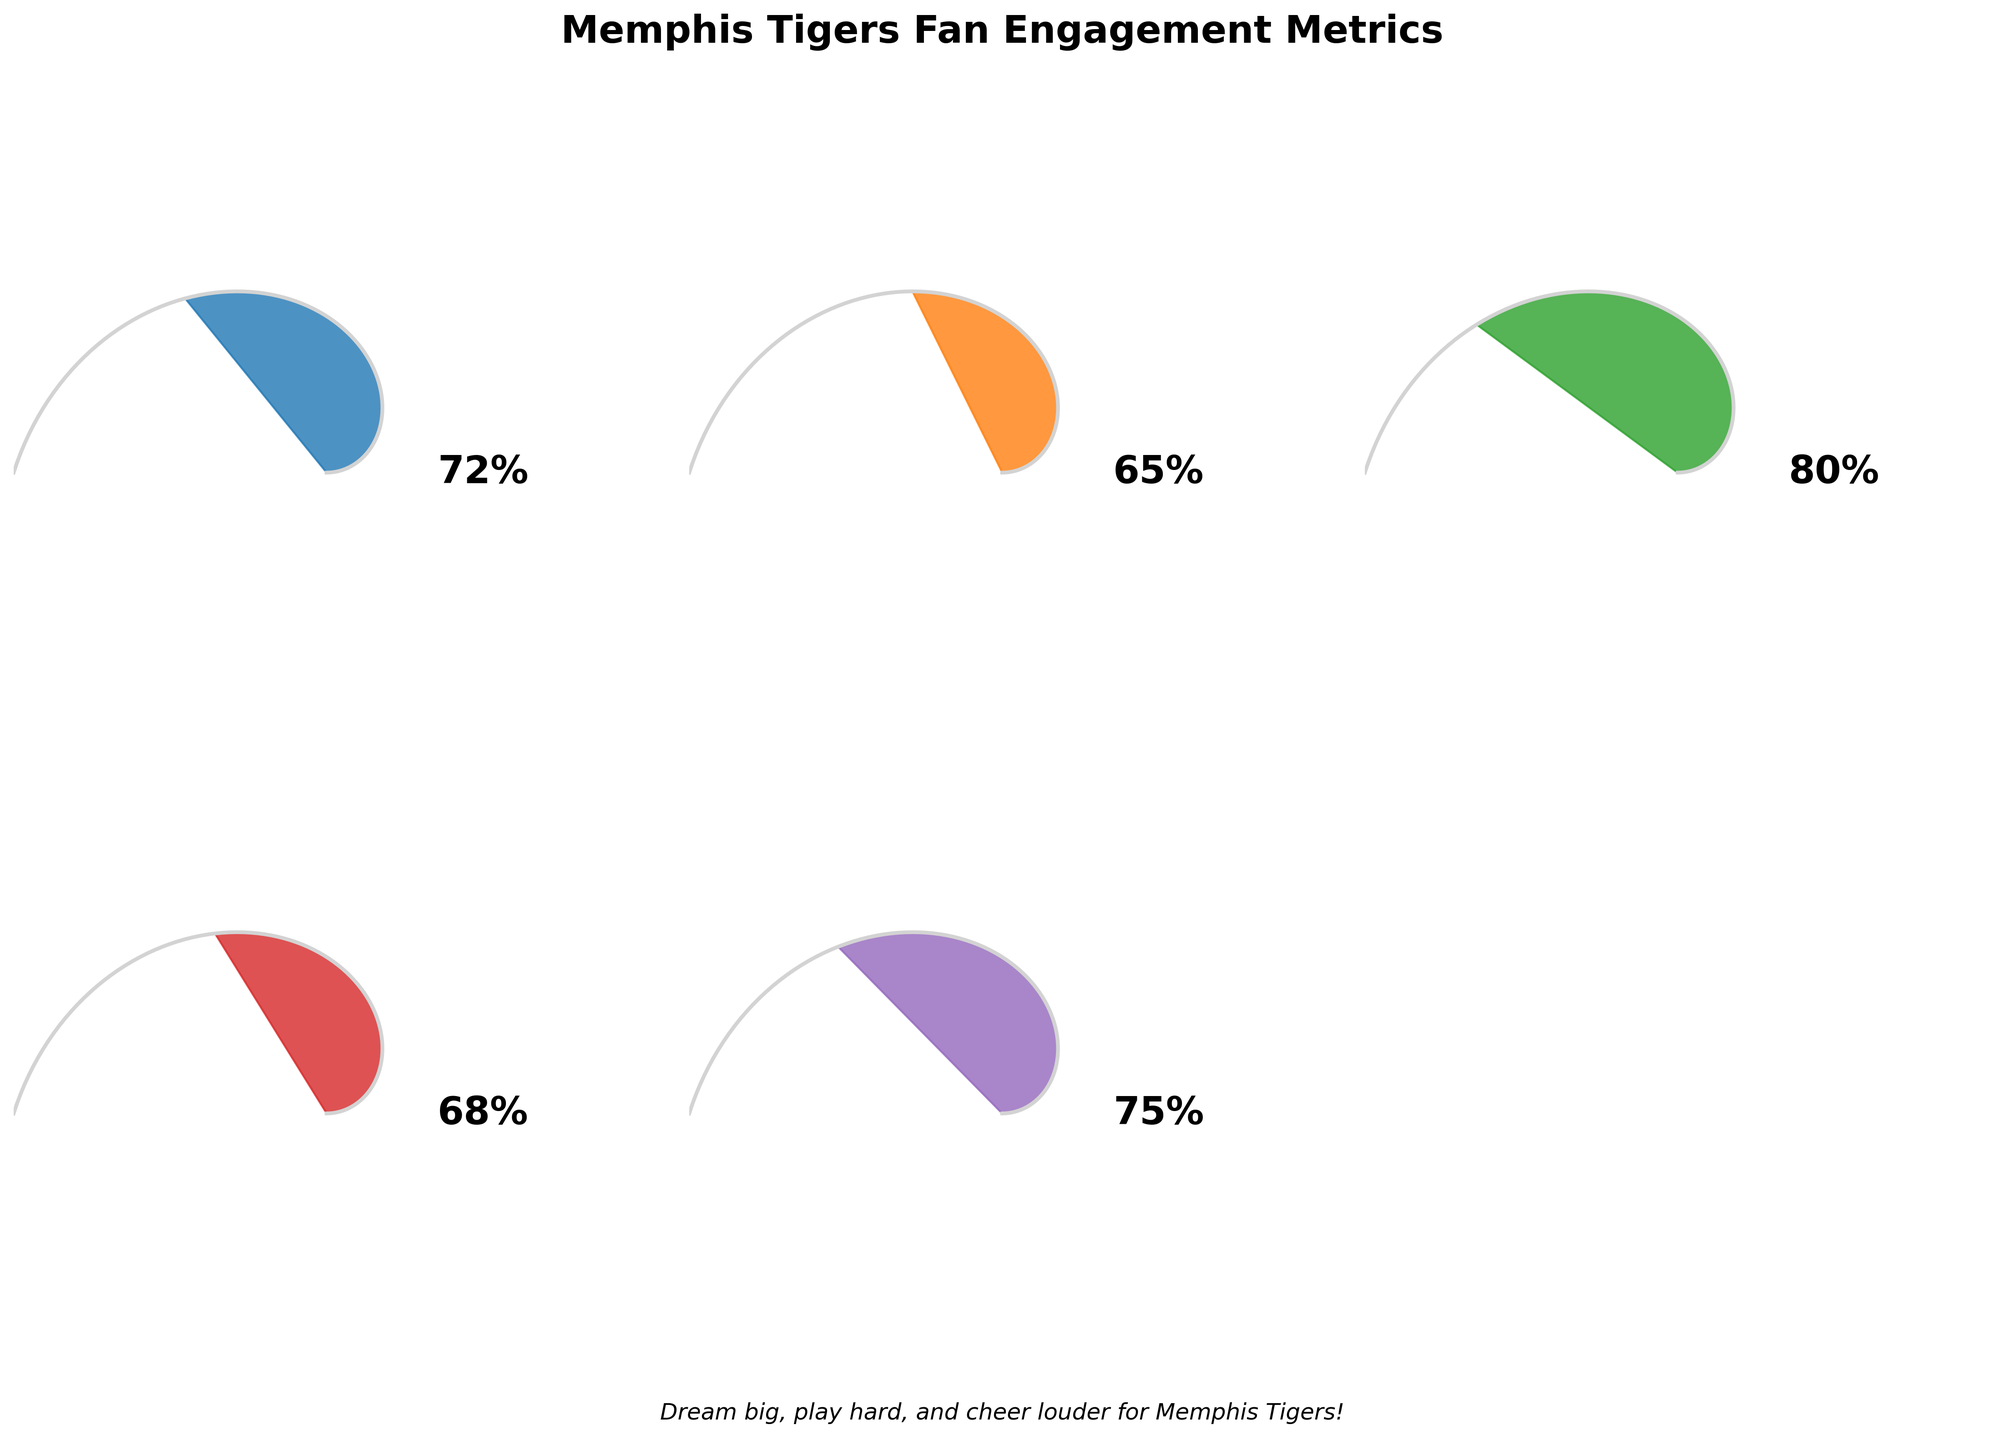What's the Memphis Tigers Fan Engagement Score? The gauge chart for Memphis Tigers Fan Engagement Score shows a value at the top, which reads 72%.
Answer: 72% How does the Liberty Bowl Memorial Stadium Attendance Rate compare to the Merchandise Sales Performance? From the two gauge charts, the Liberty Bowl Memorial Stadium Attendance Rate shows 65%, while Merchandise Sales Performance shows 68%. Thus, the Merchandise Sales Performance is a bit higher.
Answer: Merchandise Sales Performance is 3% higher Which metric scores the highest and what is its value? On examining all gauge charts, the Social Media Interaction Score has the highest value among the shown metrics, which is at 80%.
Answer: Social Media Interaction Score, 80% What is the average score across all shown metrics? Adding up all the values: 72 + 65 + 80 + 68 + 75 = 360. Dividing by the number of metrics (5) gives the average: 360 / 5 = 72.
Answer: 72 Between the Local TV Ratings for Tigers Games and Liberty Bowl Memorial Stadium Attendance Rate, which one has a superior score? Comparing the two metrics, Local TV Ratings for Tigers Games scores 75%, while Liberty Bowl Memorial Stadium Attendance Rate scores 65%. Thus, Local TV Ratings is higher.
Answer: Local TV Ratings for Tigers Games What color is used for the Social Media Interaction Score gauge? The color associated with the Social Media Interaction Score gauge is the fifth color in the sequence, a shade of green.
Answer: Green By how much does the Memphis Tigers Fan Engagement Score exceed the Local TV Ratings for Tigers Games? The Memphis Tigers Fan Engagement Score is 72%, whereas the Local TV Ratings for Tigers Games are at 75%. Therefore, it does not exceed, it is actually 3% less.
Answer: It is 3% less Which metric is 7 points higher than the Liberty Bowl Memorial Stadium Attendance Rate? The Liberty Bowl Memorial Stadium Attendance Rate is 65%. Adding 7 points to 65 gives us 72. Checking the charts, the Memphis Tigers Fan Engagement Score fits this criterion with 72%.
Answer: Memphis Tigers Fan Engagement Score What is the title of the chart? The title of the chart is prominently displayed at the top and reads "Memphis Tigers Fan Engagement Metrics".
Answer: Memphis Tigers Fan Engagement Metrics Comparing the Memphis Tigers Fan Engagement Score and the Social Media Interaction Score, which one is lower, and by how much? The Memphis Tigers Fan Engagement Score is 72%, and the Social Media Interaction Score is 80%. The Engagement Score is lower by 8%.
Answer: Memphis Tigers Fan Engagement Score, by 8% 